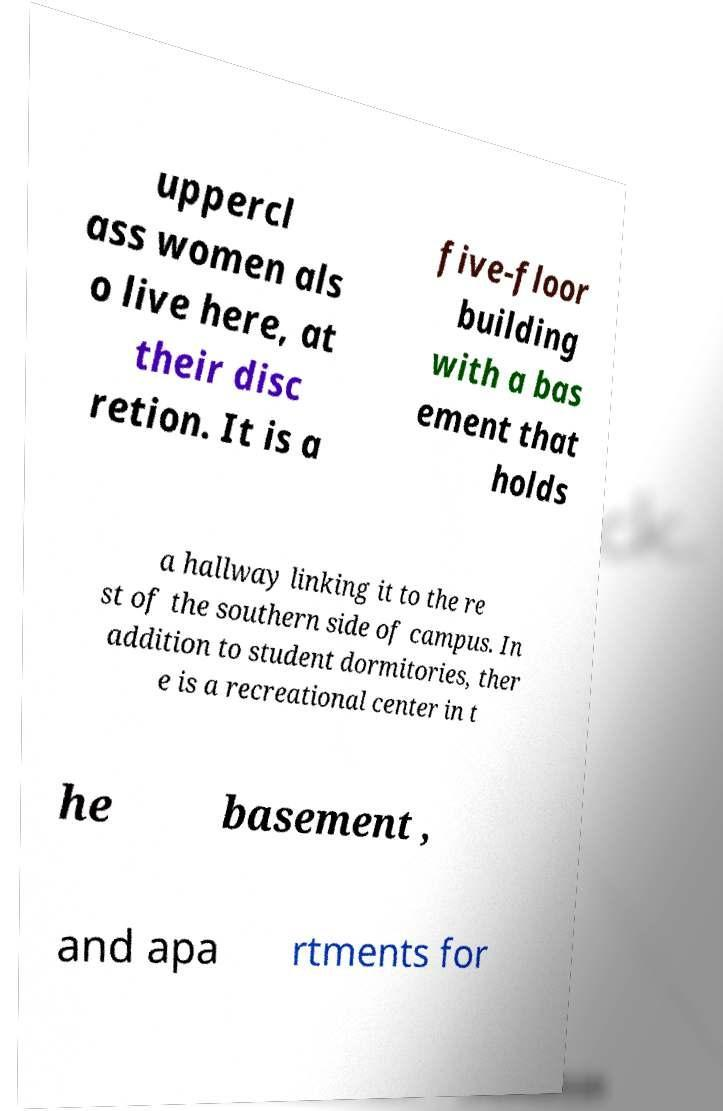Could you extract and type out the text from this image? uppercl ass women als o live here, at their disc retion. It is a five-floor building with a bas ement that holds a hallway linking it to the re st of the southern side of campus. In addition to student dormitories, ther e is a recreational center in t he basement , and apa rtments for 